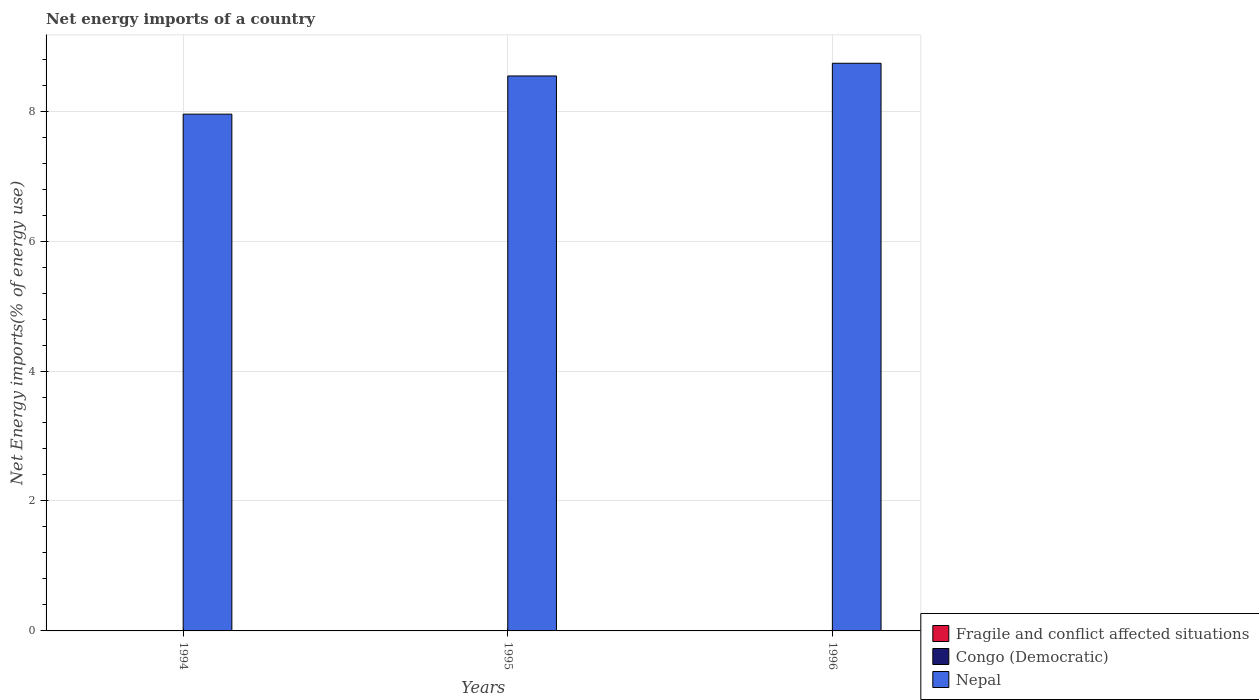How many different coloured bars are there?
Make the answer very short. 1. Are the number of bars per tick equal to the number of legend labels?
Your response must be concise. No. Are the number of bars on each tick of the X-axis equal?
Provide a short and direct response. Yes. How many bars are there on the 3rd tick from the left?
Your answer should be compact. 1. How many bars are there on the 3rd tick from the right?
Provide a succinct answer. 1. In how many cases, is the number of bars for a given year not equal to the number of legend labels?
Provide a succinct answer. 3. What is the net energy imports in Congo (Democratic) in 1994?
Your response must be concise. 0. Across all years, what is the maximum net energy imports in Nepal?
Give a very brief answer. 8.74. Across all years, what is the minimum net energy imports in Nepal?
Your response must be concise. 7.95. What is the total net energy imports in Congo (Democratic) in the graph?
Offer a terse response. 0. What is the difference between the net energy imports in Nepal in 1994 and that in 1996?
Keep it short and to the point. -0.78. What is the difference between the net energy imports in Congo (Democratic) in 1996 and the net energy imports in Nepal in 1995?
Your answer should be very brief. -8.54. What is the average net energy imports in Nepal per year?
Your answer should be compact. 8.41. What is the ratio of the net energy imports in Nepal in 1994 to that in 1995?
Offer a terse response. 0.93. What is the difference between the highest and the second highest net energy imports in Nepal?
Offer a very short reply. 0.2. What is the difference between the highest and the lowest net energy imports in Nepal?
Your response must be concise. 0.78. Is the sum of the net energy imports in Nepal in 1994 and 1996 greater than the maximum net energy imports in Congo (Democratic) across all years?
Make the answer very short. Yes. Are the values on the major ticks of Y-axis written in scientific E-notation?
Your answer should be very brief. No. Does the graph contain grids?
Make the answer very short. Yes. Where does the legend appear in the graph?
Make the answer very short. Bottom right. What is the title of the graph?
Your answer should be very brief. Net energy imports of a country. Does "Tanzania" appear as one of the legend labels in the graph?
Ensure brevity in your answer.  No. What is the label or title of the X-axis?
Offer a terse response. Years. What is the label or title of the Y-axis?
Provide a succinct answer. Net Energy imports(% of energy use). What is the Net Energy imports(% of energy use) of Congo (Democratic) in 1994?
Offer a very short reply. 0. What is the Net Energy imports(% of energy use) in Nepal in 1994?
Keep it short and to the point. 7.95. What is the Net Energy imports(% of energy use) in Nepal in 1995?
Provide a succinct answer. 8.54. What is the Net Energy imports(% of energy use) in Fragile and conflict affected situations in 1996?
Give a very brief answer. 0. What is the Net Energy imports(% of energy use) of Congo (Democratic) in 1996?
Provide a short and direct response. 0. What is the Net Energy imports(% of energy use) of Nepal in 1996?
Offer a terse response. 8.74. Across all years, what is the maximum Net Energy imports(% of energy use) in Nepal?
Your response must be concise. 8.74. Across all years, what is the minimum Net Energy imports(% of energy use) of Nepal?
Offer a terse response. 7.95. What is the total Net Energy imports(% of energy use) in Fragile and conflict affected situations in the graph?
Keep it short and to the point. 0. What is the total Net Energy imports(% of energy use) in Congo (Democratic) in the graph?
Make the answer very short. 0. What is the total Net Energy imports(% of energy use) of Nepal in the graph?
Provide a short and direct response. 25.23. What is the difference between the Net Energy imports(% of energy use) in Nepal in 1994 and that in 1995?
Offer a very short reply. -0.59. What is the difference between the Net Energy imports(% of energy use) in Nepal in 1994 and that in 1996?
Make the answer very short. -0.78. What is the difference between the Net Energy imports(% of energy use) in Nepal in 1995 and that in 1996?
Ensure brevity in your answer.  -0.2. What is the average Net Energy imports(% of energy use) of Nepal per year?
Provide a short and direct response. 8.41. What is the ratio of the Net Energy imports(% of energy use) in Nepal in 1994 to that in 1995?
Make the answer very short. 0.93. What is the ratio of the Net Energy imports(% of energy use) of Nepal in 1994 to that in 1996?
Provide a short and direct response. 0.91. What is the ratio of the Net Energy imports(% of energy use) of Nepal in 1995 to that in 1996?
Offer a very short reply. 0.98. What is the difference between the highest and the second highest Net Energy imports(% of energy use) of Nepal?
Your answer should be very brief. 0.2. What is the difference between the highest and the lowest Net Energy imports(% of energy use) of Nepal?
Ensure brevity in your answer.  0.78. 